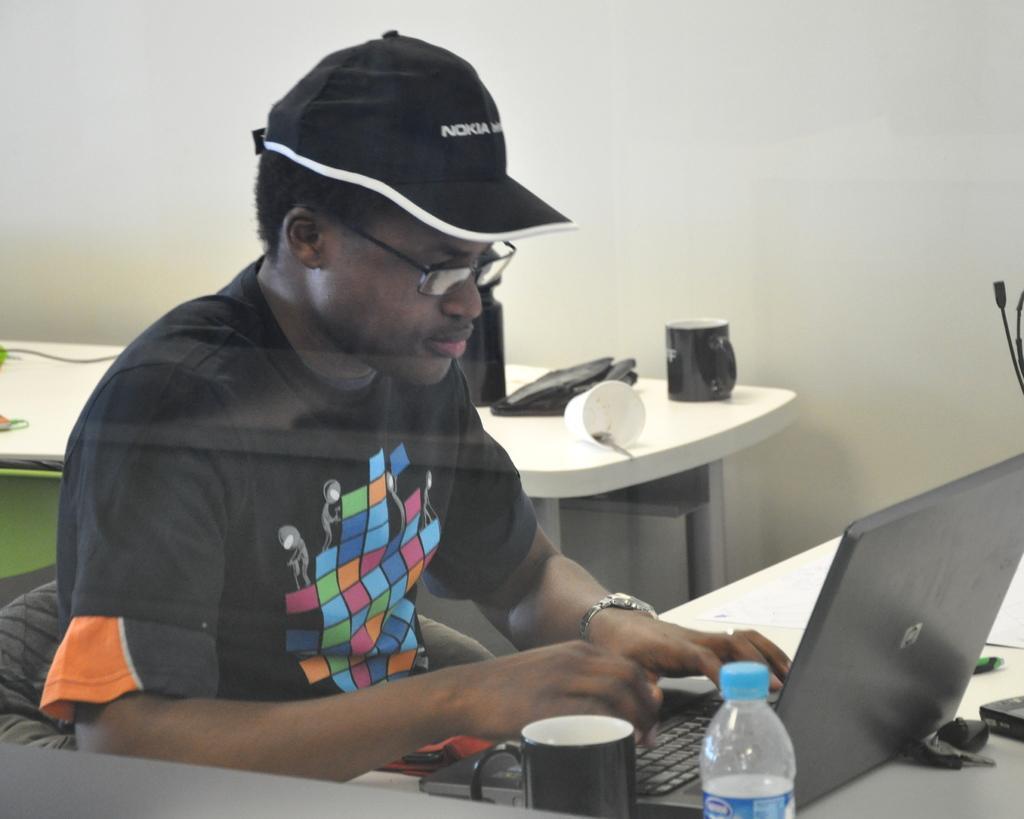Describe this image in one or two sentences. The picture contains of the person is sitting on the chair and working on the laptop and there are two tables on the table there are cup,paper cup,laptop and some keys. The background is white. 